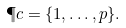<formula> <loc_0><loc_0><loc_500><loc_500>\P c = \{ 1 , \dots , p \} .</formula> 